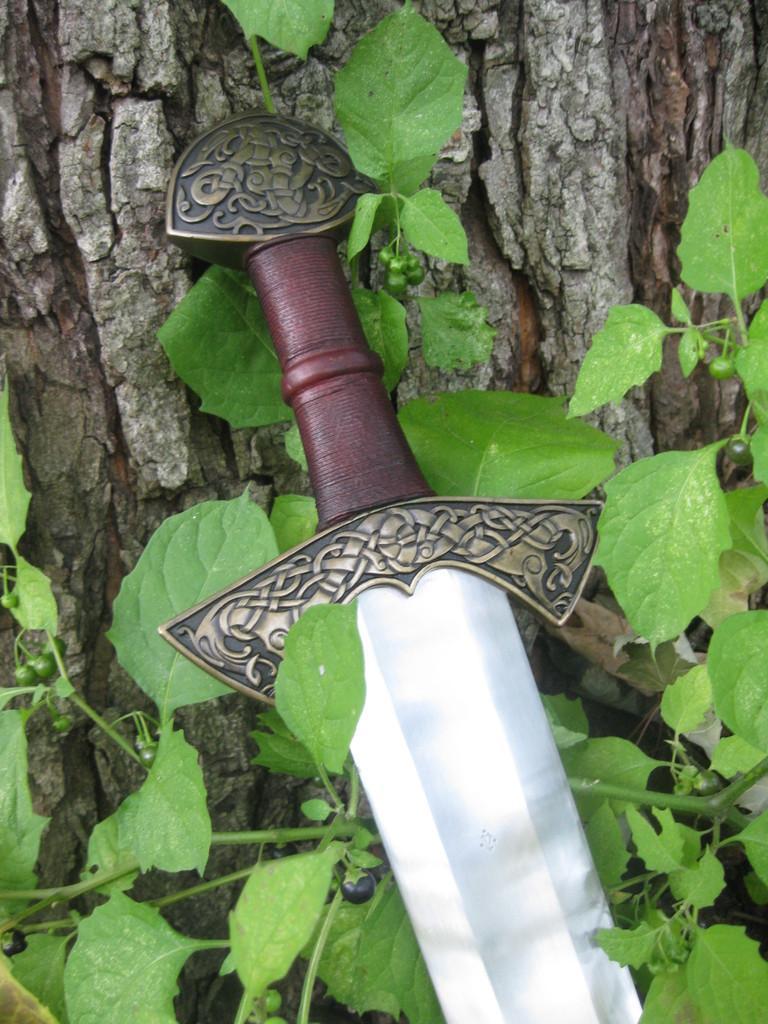Can you describe this image briefly? Here there is a sword, here there is a tree, these are plants. 